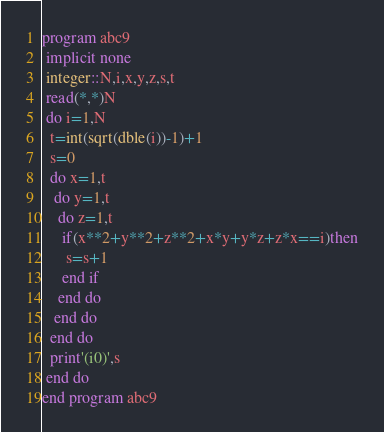Convert code to text. <code><loc_0><loc_0><loc_500><loc_500><_FORTRAN_>program abc9
 implicit none
 integer::N,i,x,y,z,s,t
 read(*,*)N
 do i=1,N
  t=int(sqrt(dble(i))-1)+1
  s=0
  do x=1,t
   do y=1,t
    do z=1,t
     if(x**2+y**2+z**2+x*y+y*z+z*x==i)then
      s=s+1
     end if
    end do
   end do
  end do
  print'(i0)',s
 end do
end program abc9</code> 